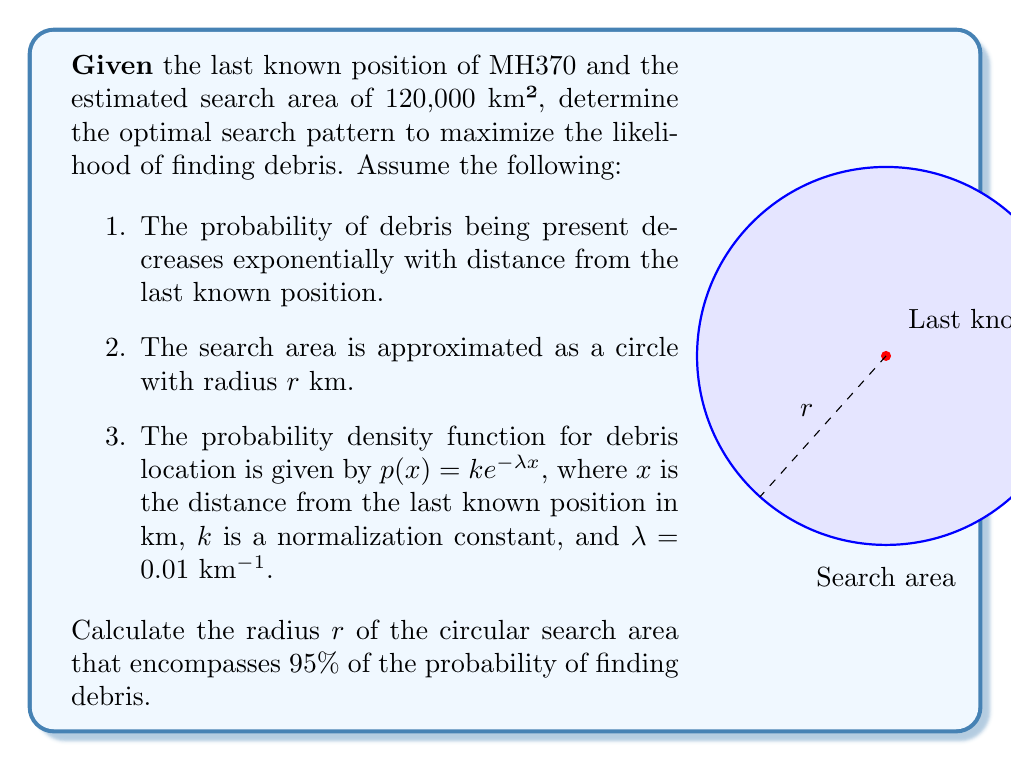Solve this math problem. Let's approach this step-by-step:

1) First, we need to normalize the probability density function. The normalization constant $k$ is determined by:

   $$\int_0^\infty ke^{-\lambda x} dx = 1$$

2) Solving this integral:

   $$k \left[-\frac{1}{\lambda}e^{-\lambda x}\right]_0^\infty = 1$$
   $$k \cdot \frac{1}{\lambda} = 1$$
   $$k = \lambda = 0.01$$

3) Now, our normalized probability density function is:

   $$p(x) = 0.01e^{-0.01x}$$

4) To find the radius $r$ that encompasses 95% of the probability, we need to solve:

   $$\int_0^r 0.01e^{-0.01x} dx = 0.95$$

5) Solving this integral:

   $$\left[-e^{-0.01x}\right]_0^r = 0.95$$
   $$-e^{-0.01r} - (-1) = 0.95$$
   $$e^{-0.01r} = 0.05$$

6) Taking the natural logarithm of both sides:

   $$-0.01r = \ln(0.05)$$
   $$r = -\frac{\ln(0.05)}{0.01}$$

7) Calculating the final value:

   $$r \approx 299.57 \text{ km}$$

8) The area of this circular search region is:

   $$A = \pi r^2 \approx 281,853 \text{ km}^2$$

This is larger than the given search area of 120,000 km², indicating that the search area should be expanded to maximize the likelihood of finding debris.
Answer: $r \approx 299.57 \text{ km}$ 